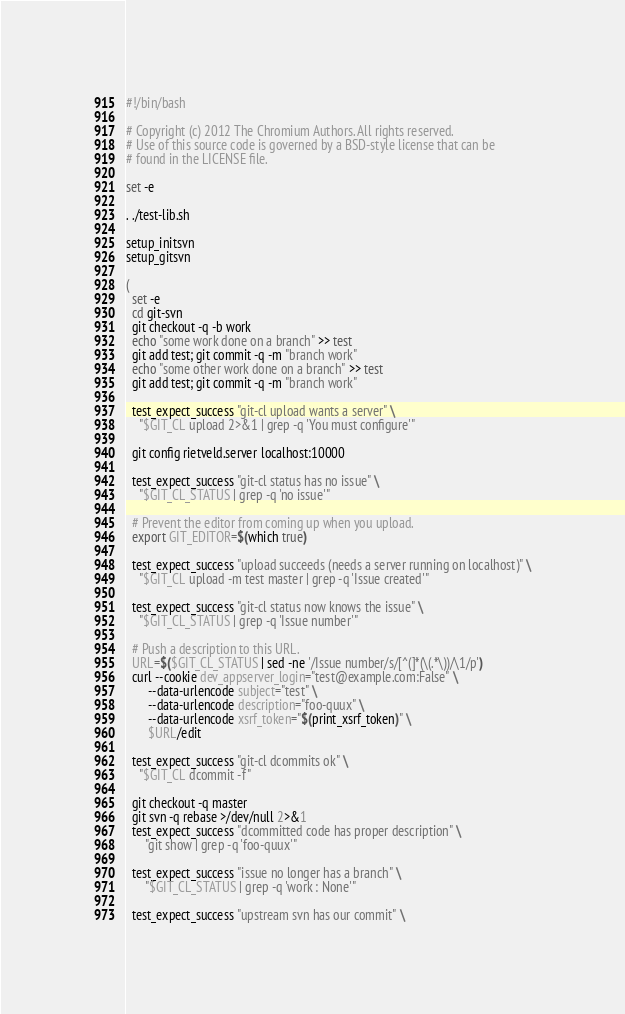<code> <loc_0><loc_0><loc_500><loc_500><_Bash_>#!/bin/bash

# Copyright (c) 2012 The Chromium Authors. All rights reserved.
# Use of this source code is governed by a BSD-style license that can be
# found in the LICENSE file.

set -e

. ./test-lib.sh

setup_initsvn
setup_gitsvn

(
  set -e
  cd git-svn
  git checkout -q -b work
  echo "some work done on a branch" >> test
  git add test; git commit -q -m "branch work"
  echo "some other work done on a branch" >> test
  git add test; git commit -q -m "branch work"

  test_expect_success "git-cl upload wants a server" \
    "$GIT_CL upload 2>&1 | grep -q 'You must configure'"

  git config rietveld.server localhost:10000

  test_expect_success "git-cl status has no issue" \
    "$GIT_CL_STATUS | grep -q 'no issue'"

  # Prevent the editor from coming up when you upload.
  export GIT_EDITOR=$(which true)

  test_expect_success "upload succeeds (needs a server running on localhost)" \
    "$GIT_CL upload -m test master | grep -q 'Issue created'"

  test_expect_success "git-cl status now knows the issue" \
    "$GIT_CL_STATUS | grep -q 'Issue number'"

  # Push a description to this URL.
  URL=$($GIT_CL_STATUS | sed -ne '/Issue number/s/[^(]*(\(.*\))/\1/p')
  curl --cookie dev_appserver_login="test@example.com:False" \
       --data-urlencode subject="test" \
       --data-urlencode description="foo-quux" \
       --data-urlencode xsrf_token="$(print_xsrf_token)" \
       $URL/edit

  test_expect_success "git-cl dcommits ok" \
    "$GIT_CL dcommit -f"

  git checkout -q master
  git svn -q rebase >/dev/null 2>&1
  test_expect_success "dcommitted code has proper description" \
      "git show | grep -q 'foo-quux'"

  test_expect_success "issue no longer has a branch" \
      "$GIT_CL_STATUS | grep -q 'work : None'"

  test_expect_success "upstream svn has our commit" \</code> 